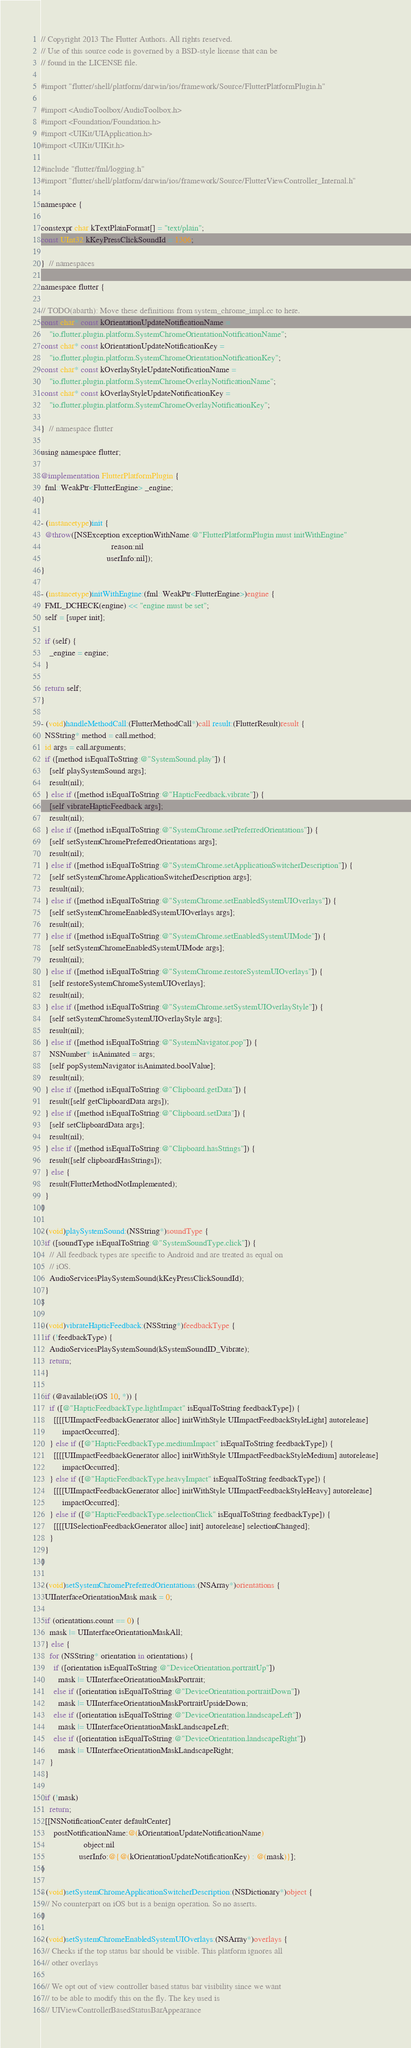<code> <loc_0><loc_0><loc_500><loc_500><_ObjectiveC_>// Copyright 2013 The Flutter Authors. All rights reserved.
// Use of this source code is governed by a BSD-style license that can be
// found in the LICENSE file.

#import "flutter/shell/platform/darwin/ios/framework/Source/FlutterPlatformPlugin.h"

#import <AudioToolbox/AudioToolbox.h>
#import <Foundation/Foundation.h>
#import <UIKit/UIApplication.h>
#import <UIKit/UIKit.h>

#include "flutter/fml/logging.h"
#import "flutter/shell/platform/darwin/ios/framework/Source/FlutterViewController_Internal.h"

namespace {

constexpr char kTextPlainFormat[] = "text/plain";
const UInt32 kKeyPressClickSoundId = 1306;

}  // namespaces

namespace flutter {

// TODO(abarth): Move these definitions from system_chrome_impl.cc to here.
const char* const kOrientationUpdateNotificationName =
    "io.flutter.plugin.platform.SystemChromeOrientationNotificationName";
const char* const kOrientationUpdateNotificationKey =
    "io.flutter.plugin.platform.SystemChromeOrientationNotificationKey";
const char* const kOverlayStyleUpdateNotificationName =
    "io.flutter.plugin.platform.SystemChromeOverlayNotificationName";
const char* const kOverlayStyleUpdateNotificationKey =
    "io.flutter.plugin.platform.SystemChromeOverlayNotificationKey";

}  // namespace flutter

using namespace flutter;

@implementation FlutterPlatformPlugin {
  fml::WeakPtr<FlutterEngine> _engine;
}

- (instancetype)init {
  @throw([NSException exceptionWithName:@"FlutterPlatformPlugin must initWithEngine"
                                 reason:nil
                               userInfo:nil]);
}

- (instancetype)initWithEngine:(fml::WeakPtr<FlutterEngine>)engine {
  FML_DCHECK(engine) << "engine must be set";
  self = [super init];

  if (self) {
    _engine = engine;
  }

  return self;
}

- (void)handleMethodCall:(FlutterMethodCall*)call result:(FlutterResult)result {
  NSString* method = call.method;
  id args = call.arguments;
  if ([method isEqualToString:@"SystemSound.play"]) {
    [self playSystemSound:args];
    result(nil);
  } else if ([method isEqualToString:@"HapticFeedback.vibrate"]) {
    [self vibrateHapticFeedback:args];
    result(nil);
  } else if ([method isEqualToString:@"SystemChrome.setPreferredOrientations"]) {
    [self setSystemChromePreferredOrientations:args];
    result(nil);
  } else if ([method isEqualToString:@"SystemChrome.setApplicationSwitcherDescription"]) {
    [self setSystemChromeApplicationSwitcherDescription:args];
    result(nil);
  } else if ([method isEqualToString:@"SystemChrome.setEnabledSystemUIOverlays"]) {
    [self setSystemChromeEnabledSystemUIOverlays:args];
    result(nil);
  } else if ([method isEqualToString:@"SystemChrome.setEnabledSystemUIMode"]) {
    [self setSystemChromeEnabledSystemUIMode:args];
    result(nil);
  } else if ([method isEqualToString:@"SystemChrome.restoreSystemUIOverlays"]) {
    [self restoreSystemChromeSystemUIOverlays];
    result(nil);
  } else if ([method isEqualToString:@"SystemChrome.setSystemUIOverlayStyle"]) {
    [self setSystemChromeSystemUIOverlayStyle:args];
    result(nil);
  } else if ([method isEqualToString:@"SystemNavigator.pop"]) {
    NSNumber* isAnimated = args;
    [self popSystemNavigator:isAnimated.boolValue];
    result(nil);
  } else if ([method isEqualToString:@"Clipboard.getData"]) {
    result([self getClipboardData:args]);
  } else if ([method isEqualToString:@"Clipboard.setData"]) {
    [self setClipboardData:args];
    result(nil);
  } else if ([method isEqualToString:@"Clipboard.hasStrings"]) {
    result([self clipboardHasStrings]);
  } else {
    result(FlutterMethodNotImplemented);
  }
}

- (void)playSystemSound:(NSString*)soundType {
  if ([soundType isEqualToString:@"SystemSoundType.click"]) {
    // All feedback types are specific to Android and are treated as equal on
    // iOS.
    AudioServicesPlaySystemSound(kKeyPressClickSoundId);
  }
}

- (void)vibrateHapticFeedback:(NSString*)feedbackType {
  if (!feedbackType) {
    AudioServicesPlaySystemSound(kSystemSoundID_Vibrate);
    return;
  }

  if (@available(iOS 10, *)) {
    if ([@"HapticFeedbackType.lightImpact" isEqualToString:feedbackType]) {
      [[[[UIImpactFeedbackGenerator alloc] initWithStyle:UIImpactFeedbackStyleLight] autorelease]
          impactOccurred];
    } else if ([@"HapticFeedbackType.mediumImpact" isEqualToString:feedbackType]) {
      [[[[UIImpactFeedbackGenerator alloc] initWithStyle:UIImpactFeedbackStyleMedium] autorelease]
          impactOccurred];
    } else if ([@"HapticFeedbackType.heavyImpact" isEqualToString:feedbackType]) {
      [[[[UIImpactFeedbackGenerator alloc] initWithStyle:UIImpactFeedbackStyleHeavy] autorelease]
          impactOccurred];
    } else if ([@"HapticFeedbackType.selectionClick" isEqualToString:feedbackType]) {
      [[[[UISelectionFeedbackGenerator alloc] init] autorelease] selectionChanged];
    }
  }
}

- (void)setSystemChromePreferredOrientations:(NSArray*)orientations {
  UIInterfaceOrientationMask mask = 0;

  if (orientations.count == 0) {
    mask |= UIInterfaceOrientationMaskAll;
  } else {
    for (NSString* orientation in orientations) {
      if ([orientation isEqualToString:@"DeviceOrientation.portraitUp"])
        mask |= UIInterfaceOrientationMaskPortrait;
      else if ([orientation isEqualToString:@"DeviceOrientation.portraitDown"])
        mask |= UIInterfaceOrientationMaskPortraitUpsideDown;
      else if ([orientation isEqualToString:@"DeviceOrientation.landscapeLeft"])
        mask |= UIInterfaceOrientationMaskLandscapeLeft;
      else if ([orientation isEqualToString:@"DeviceOrientation.landscapeRight"])
        mask |= UIInterfaceOrientationMaskLandscapeRight;
    }
  }

  if (!mask)
    return;
  [[NSNotificationCenter defaultCenter]
      postNotificationName:@(kOrientationUpdateNotificationName)
                    object:nil
                  userInfo:@{@(kOrientationUpdateNotificationKey) : @(mask)}];
}

- (void)setSystemChromeApplicationSwitcherDescription:(NSDictionary*)object {
  // No counterpart on iOS but is a benign operation. So no asserts.
}

- (void)setSystemChromeEnabledSystemUIOverlays:(NSArray*)overlays {
  // Checks if the top status bar should be visible. This platform ignores all
  // other overlays

  // We opt out of view controller based status bar visibility since we want
  // to be able to modify this on the fly. The key used is
  // UIViewControllerBasedStatusBarAppearance</code> 